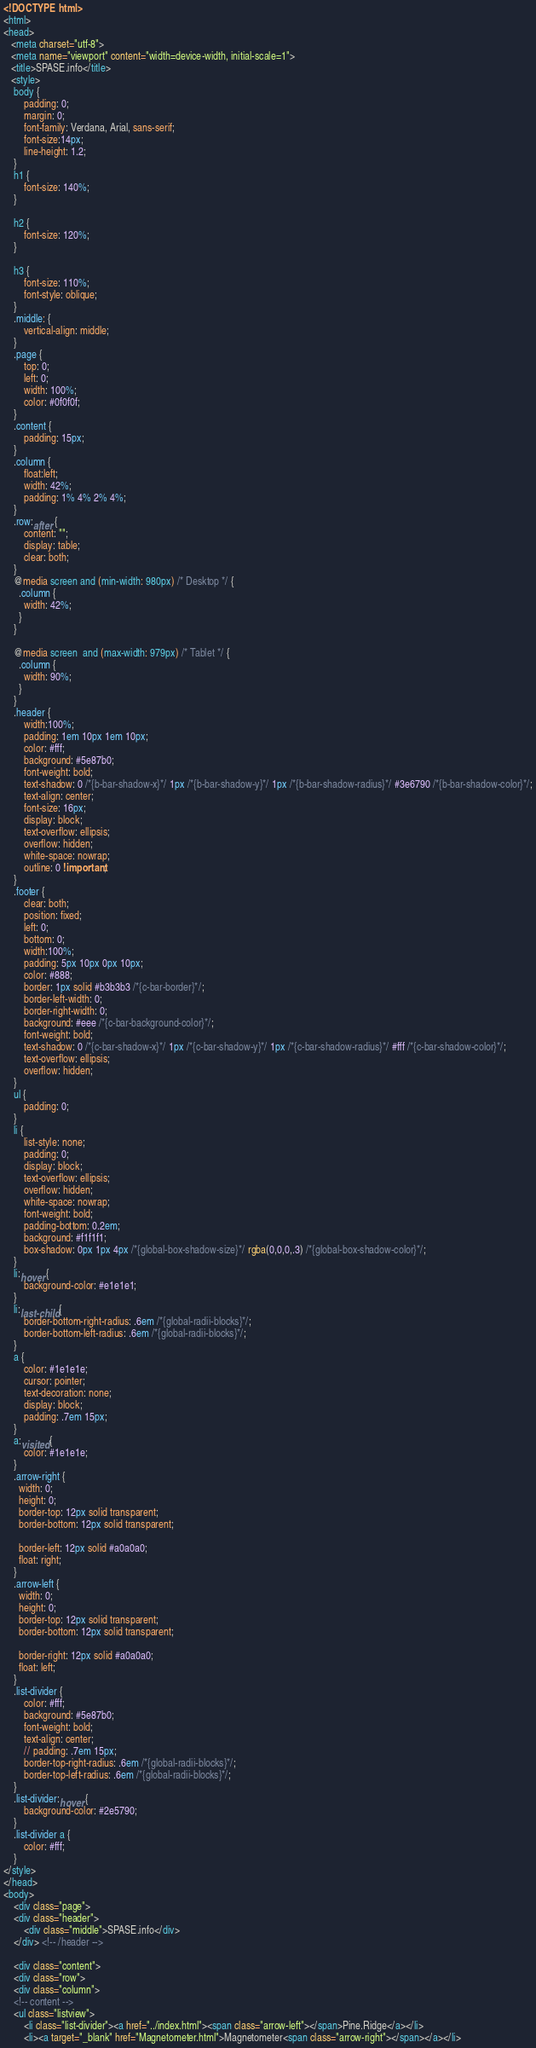<code> <loc_0><loc_0><loc_500><loc_500><_HTML_><!DOCTYPE html>
<html>
<head>
   <meta charset="utf-8">
   <meta name="viewport" content="width=device-width, initial-scale=1">
   <title>SPASE.info</title>
   <style>
	body {
		padding: 0;
		margin: 0;
		font-family: Verdana, Arial, sans-serif; 
		font-size:14px; 
		line-height: 1.2;
	}
	h1 {
		font-size: 140%;
	}

	h2 {
		font-size: 120%;
	}

	h3 {
		font-size: 110%;
		font-style: oblique;
	}
	.middle: {
		vertical-align: middle;
	}
	.page {
		top: 0;
		left: 0;
		width: 100%;
		color: #0f0f0f;
	}
	.content {
		padding: 15px;
	}
	.column {
		float:left;
		width: 42%;
		padding: 1% 4% 2% 4%;
	}
	.row:after {
		content: "";
		display: table;
		clear: both;
	}	
	@media screen and (min-width: 980px) /* Desktop */ {
	  .column {
		width: 42%;
	  }
	}

	@media screen  and (max-width: 979px) /* Tablet */ {
	  .column {
		width: 90%;
	  }
	}
	.header {
		width:100%;
		padding: 1em 10px 1em 10px;
		color: #fff;
		background: #5e87b0;
		font-weight: bold;
		text-shadow: 0 /*{b-bar-shadow-x}*/ 1px /*{b-bar-shadow-y}*/ 1px /*{b-bar-shadow-radius}*/ #3e6790 /*{b-bar-shadow-color}*/;
		text-align: center;
		font-size: 16px;
		display: block;
		text-overflow: ellipsis;
		overflow: hidden;
		white-space: nowrap;
		outline: 0 !important;
	}
	.footer {
		clear: both;
		position: fixed;
		left: 0;
		bottom: 0;
		width:100%;
		padding: 5px 10px 0px 10px;
		color: #888;
		border: 1px solid #b3b3b3 /*{c-bar-border}*/;
		border-left-width: 0;
		border-right-width: 0;
		background: #eee /*{c-bar-background-color}*/;
		font-weight: bold;
		text-shadow: 0 /*{c-bar-shadow-x}*/ 1px /*{c-bar-shadow-y}*/ 1px /*{c-bar-shadow-radius}*/ #fff /*{c-bar-shadow-color}*/;
		text-overflow: ellipsis;
		overflow: hidden;
	}
	ul {
		padding: 0;
	}
	li {
		list-style: none;
		padding: 0;
		display: block;
	    text-overflow: ellipsis;
		overflow: hidden;
		white-space: nowrap;
		font-weight: bold;
		padding-bottom: 0.2em;
		background: #f1f1f1;
		box-shadow: 0px 1px 4px /*{global-box-shadow-size}*/ rgba(0,0,0,.3) /*{global-box-shadow-color}*/;
	}
	li:hover {
		background-color: #e1e1e1;
	}
	li:last-child {
		border-bottom-right-radius: .6em /*{global-radii-blocks}*/;
		border-bottom-left-radius: .6em /*{global-radii-blocks}*/;
	}
	a {
		color: #1e1e1e;
		cursor: pointer;
		text-decoration: none;
		display: block;
		padding: .7em 15px;
	}
	a:visited {
		color: #1e1e1e;
	}
	.arrow-right {
	  width: 0; 
	  height: 0; 
	  border-top: 12px solid transparent;
	  border-bottom: 12px solid transparent;
	  
	  border-left: 12px solid #a0a0a0;
	  float: right;
	}
	.arrow-left {
	  width: 0; 
	  height: 0; 
	  border-top: 12px solid transparent;
	  border-bottom: 12px solid transparent;
	  
	  border-right: 12px solid #a0a0a0;
	  float: left;
	}
	.list-divider {
		color: #fff;
		background: #5e87b0;
		font-weight: bold;
		text-align: center;
		// padding: .7em 15px;
		border-top-right-radius: .6em /*{global-radii-blocks}*/;
		border-top-left-radius: .6em /*{global-radii-blocks}*/;
	}
	.list-divider:hover {
		background-color: #2e5790;
	}
	.list-divider a {
		color: #fff;
	}
</style>
</head>
<body>
	<div class="page">
	<div class="header">
		<div class="middle">SPASE.info</div>
	</div> <!-- /header -->
	
	<div class="content">
	<div class="row">
	<div class="column">
	<!-- content -->
	<ul class="listview">
		<li class="list-divider"><a href="../index.html"><span class="arrow-left"></span>Pine.Ridge</a></li>
		<li><a target="_blank" href="Magnetometer.html">Magnetometer<span class="arrow-right"></span></a></li></code> 